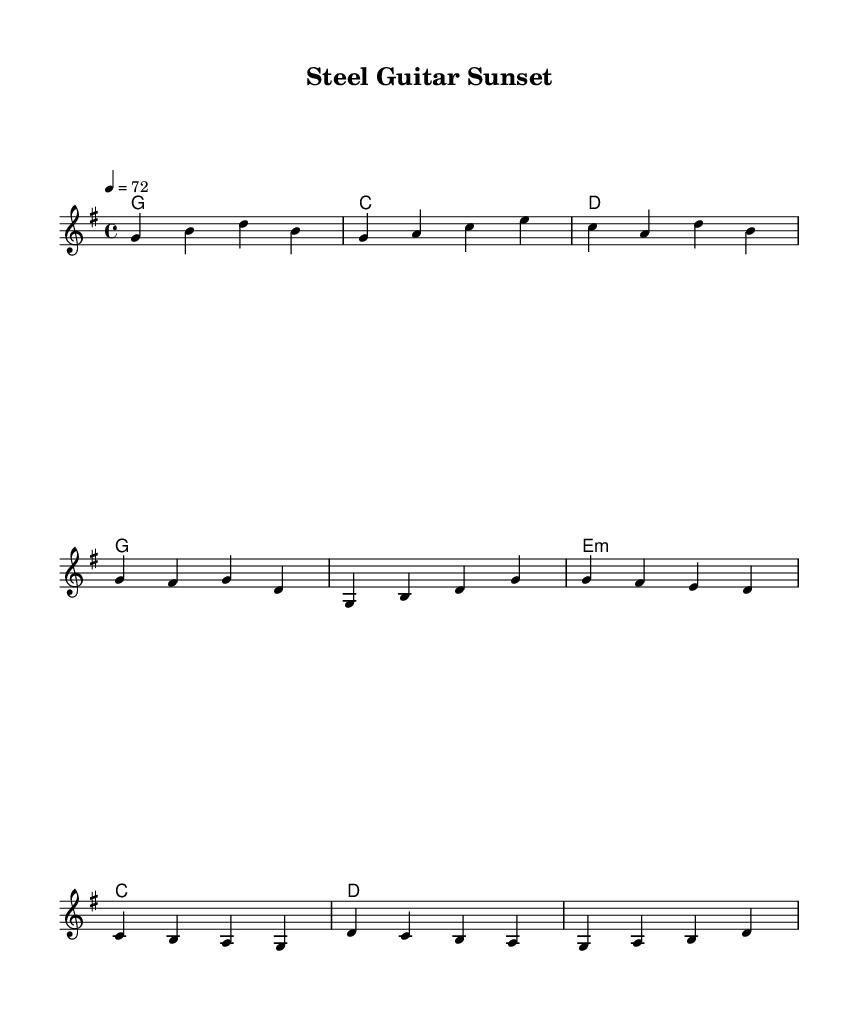What is the key signature of this music? The key signature is G major, which has one sharp (F#).
Answer: G major What is the time signature of the piece? The time signature shown in the music is 4/4, meaning there are four beats per measure.
Answer: 4/4 What is the tempo marking of the piece? The tempo marking indicates a speed of quarter note equals 72 beats per minute.
Answer: 72 What is the first chord in the verse? The first chord indicated in the verse is G major, shown in the chord line below the melody.
Answer: G How many measures are in the chorus? The chorus consists of four measures, as indicated by the grouping of chords under the corresponding melody notes.
Answer: 4 What type of musical elements are primarily used in this ballad? The pieces feature a blend of both melodic lines and harmonies, showcasing the essence of a ballad within a metal context.
Answer: Melodies and harmonies What is the relationship between the chorus and the verse motifs? The motifs in the chorus often resolve back to notes found in the verse, creating a sense of coherence and unity in the piece's structure.
Answer: Coherence and unity 